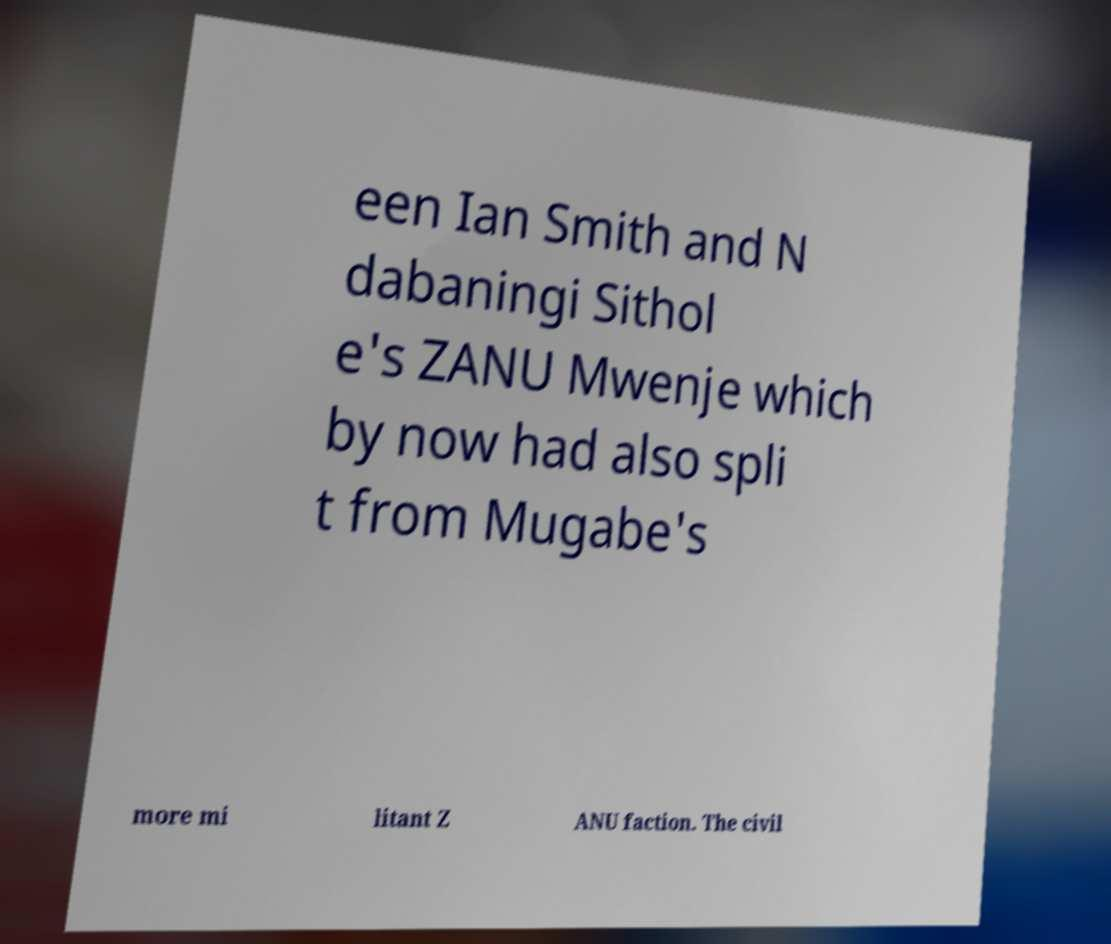Please read and relay the text visible in this image. What does it say? een Ian Smith and N dabaningi Sithol e's ZANU Mwenje which by now had also spli t from Mugabe's more mi litant Z ANU faction. The civil 